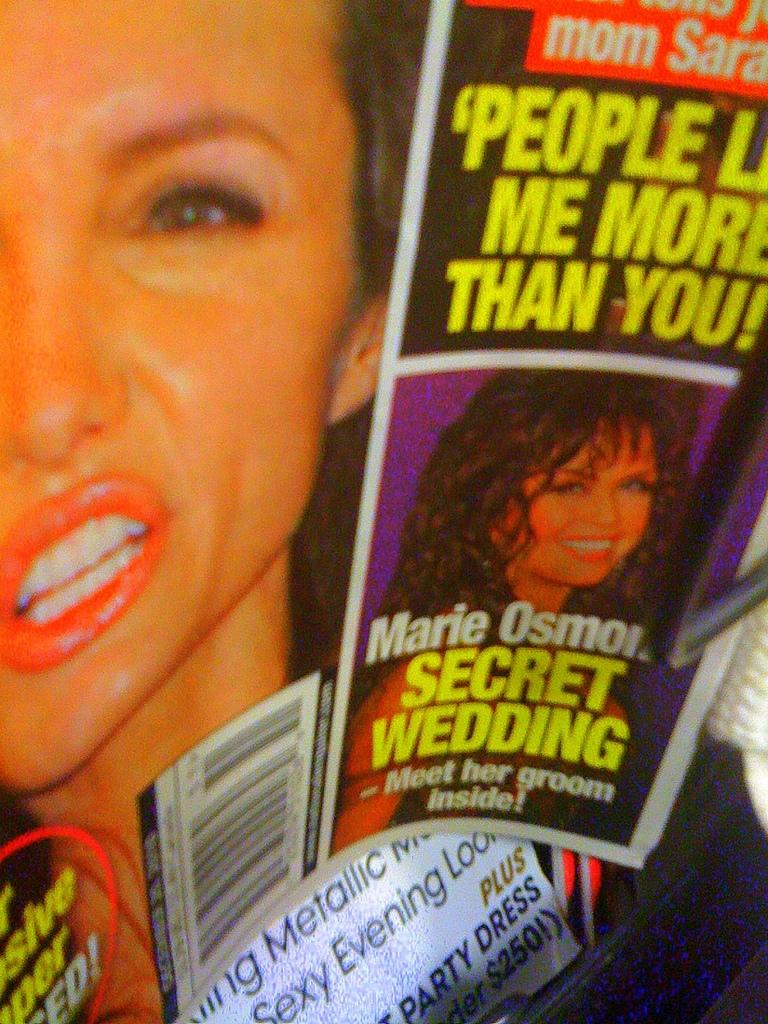<image>
Render a clear and concise summary of the photo. A magazine features an article about Marie Osmond and her secret wedding 